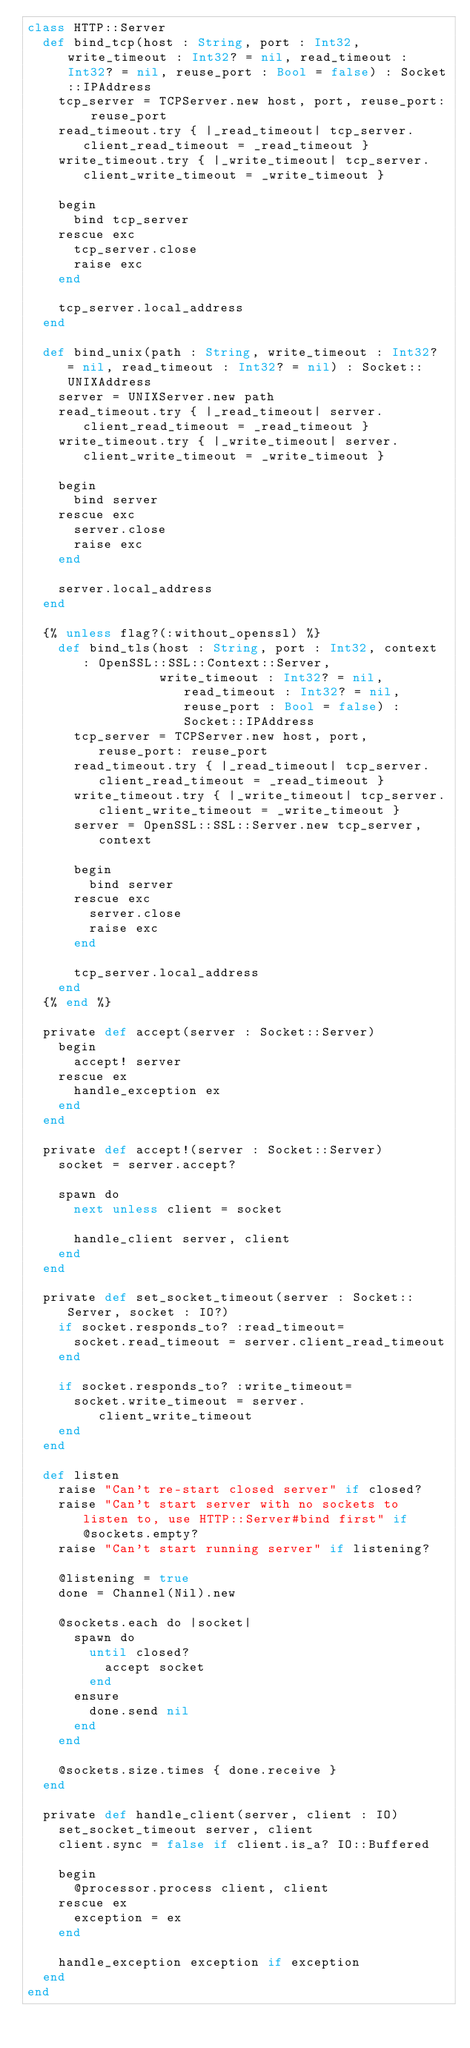<code> <loc_0><loc_0><loc_500><loc_500><_Crystal_>class HTTP::Server
  def bind_tcp(host : String, port : Int32, write_timeout : Int32? = nil, read_timeout : Int32? = nil, reuse_port : Bool = false) : Socket::IPAddress
    tcp_server = TCPServer.new host, port, reuse_port: reuse_port
    read_timeout.try { |_read_timeout| tcp_server.client_read_timeout = _read_timeout }
    write_timeout.try { |_write_timeout| tcp_server.client_write_timeout = _write_timeout }

    begin
      bind tcp_server
    rescue exc
      tcp_server.close
      raise exc
    end

    tcp_server.local_address
  end

  def bind_unix(path : String, write_timeout : Int32? = nil, read_timeout : Int32? = nil) : Socket::UNIXAddress
    server = UNIXServer.new path
    read_timeout.try { |_read_timeout| server.client_read_timeout = _read_timeout }
    write_timeout.try { |_write_timeout| server.client_write_timeout = _write_timeout }

    begin
      bind server
    rescue exc
      server.close
      raise exc
    end

    server.local_address
  end

  {% unless flag?(:without_openssl) %}
    def bind_tls(host : String, port : Int32, context : OpenSSL::SSL::Context::Server,
                 write_timeout : Int32? = nil, read_timeout : Int32? = nil, reuse_port : Bool = false) : Socket::IPAddress
      tcp_server = TCPServer.new host, port, reuse_port: reuse_port
      read_timeout.try { |_read_timeout| tcp_server.client_read_timeout = _read_timeout }
      write_timeout.try { |_write_timeout| tcp_server.client_write_timeout = _write_timeout }
      server = OpenSSL::SSL::Server.new tcp_server, context

      begin
        bind server
      rescue exc
        server.close
        raise exc
      end

      tcp_server.local_address
    end
  {% end %}

  private def accept(server : Socket::Server)
    begin
      accept! server
    rescue ex
      handle_exception ex
    end
  end

  private def accept!(server : Socket::Server)
    socket = server.accept?

    spawn do
      next unless client = socket

      handle_client server, client
    end
  end

  private def set_socket_timeout(server : Socket::Server, socket : IO?)
    if socket.responds_to? :read_timeout=
      socket.read_timeout = server.client_read_timeout
    end

    if socket.responds_to? :write_timeout=
      socket.write_timeout = server.client_write_timeout
    end
  end

  def listen
    raise "Can't re-start closed server" if closed?
    raise "Can't start server with no sockets to listen to, use HTTP::Server#bind first" if @sockets.empty?
    raise "Can't start running server" if listening?

    @listening = true
    done = Channel(Nil).new

    @sockets.each do |socket|
      spawn do
        until closed?
          accept socket
        end
      ensure
        done.send nil
      end
    end

    @sockets.size.times { done.receive }
  end

  private def handle_client(server, client : IO)
    set_socket_timeout server, client
    client.sync = false if client.is_a? IO::Buffered

    begin
      @processor.process client, client
    rescue ex
      exception = ex
    end

    handle_exception exception if exception
  end
end
</code> 